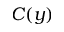<formula> <loc_0><loc_0><loc_500><loc_500>C ( y )</formula> 